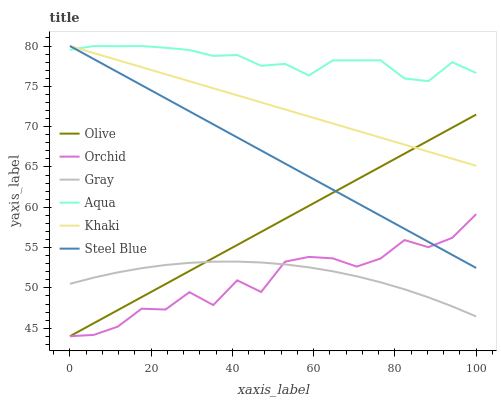Does Khaki have the minimum area under the curve?
Answer yes or no. No. Does Khaki have the maximum area under the curve?
Answer yes or no. No. Is Khaki the smoothest?
Answer yes or no. No. Is Khaki the roughest?
Answer yes or no. No. Does Khaki have the lowest value?
Answer yes or no. No. Does Olive have the highest value?
Answer yes or no. No. Is Gray less than Aqua?
Answer yes or no. Yes. Is Khaki greater than Orchid?
Answer yes or no. Yes. Does Gray intersect Aqua?
Answer yes or no. No. 